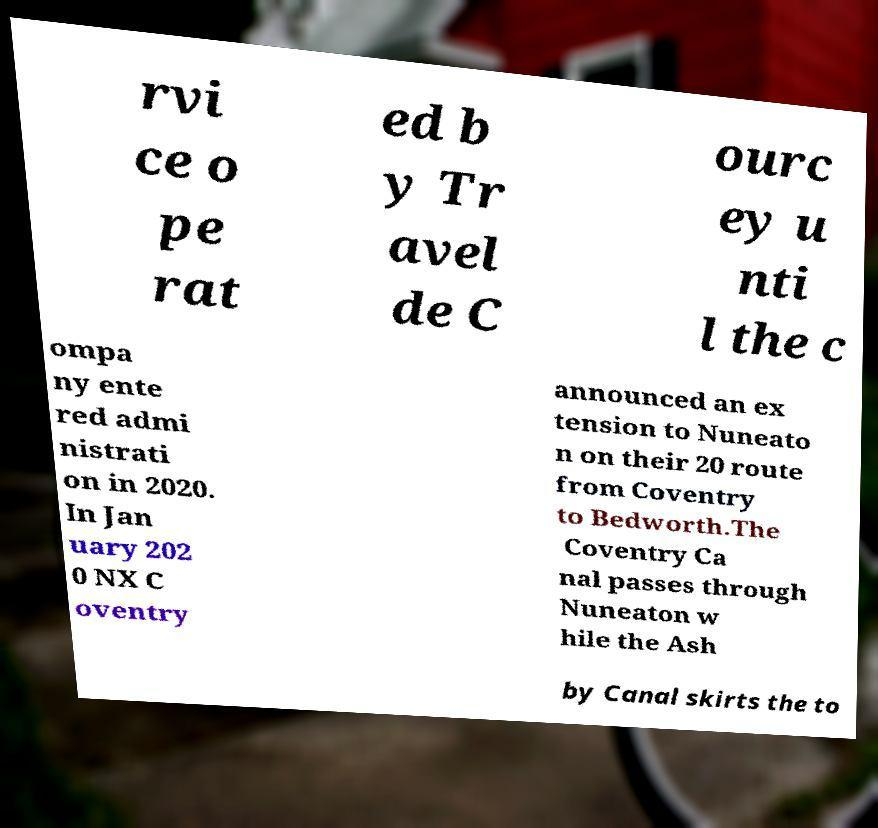Please read and relay the text visible in this image. What does it say? rvi ce o pe rat ed b y Tr avel de C ourc ey u nti l the c ompa ny ente red admi nistrati on in 2020. In Jan uary 202 0 NX C oventry announced an ex tension to Nuneato n on their 20 route from Coventry to Bedworth.The Coventry Ca nal passes through Nuneaton w hile the Ash by Canal skirts the to 